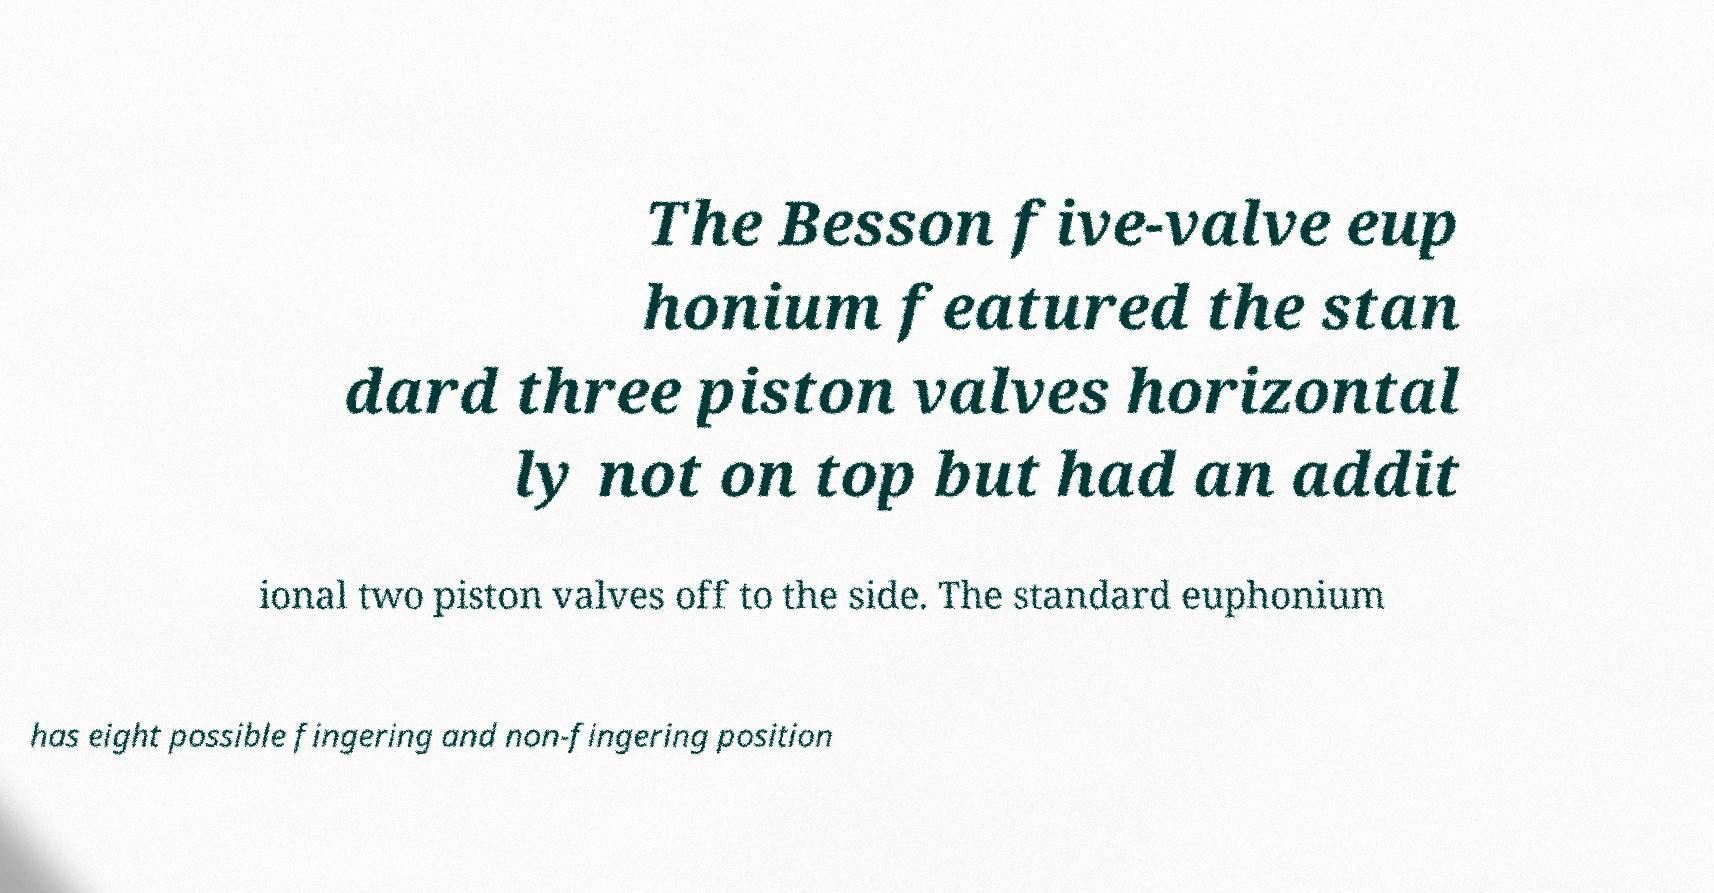Can you read and provide the text displayed in the image?This photo seems to have some interesting text. Can you extract and type it out for me? The Besson five-valve eup honium featured the stan dard three piston valves horizontal ly not on top but had an addit ional two piston valves off to the side. The standard euphonium has eight possible fingering and non-fingering position 